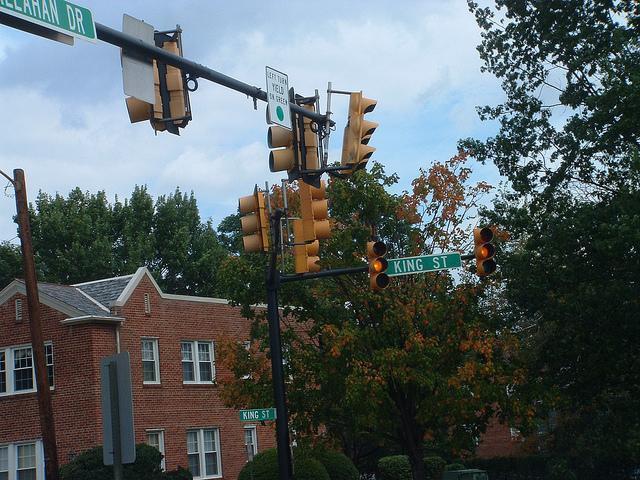Who would be married to the person that is listed on the street name?
From the following four choices, select the correct answer to address the question.
Options: Dauphine, princess, queen, duchess. Queen. 